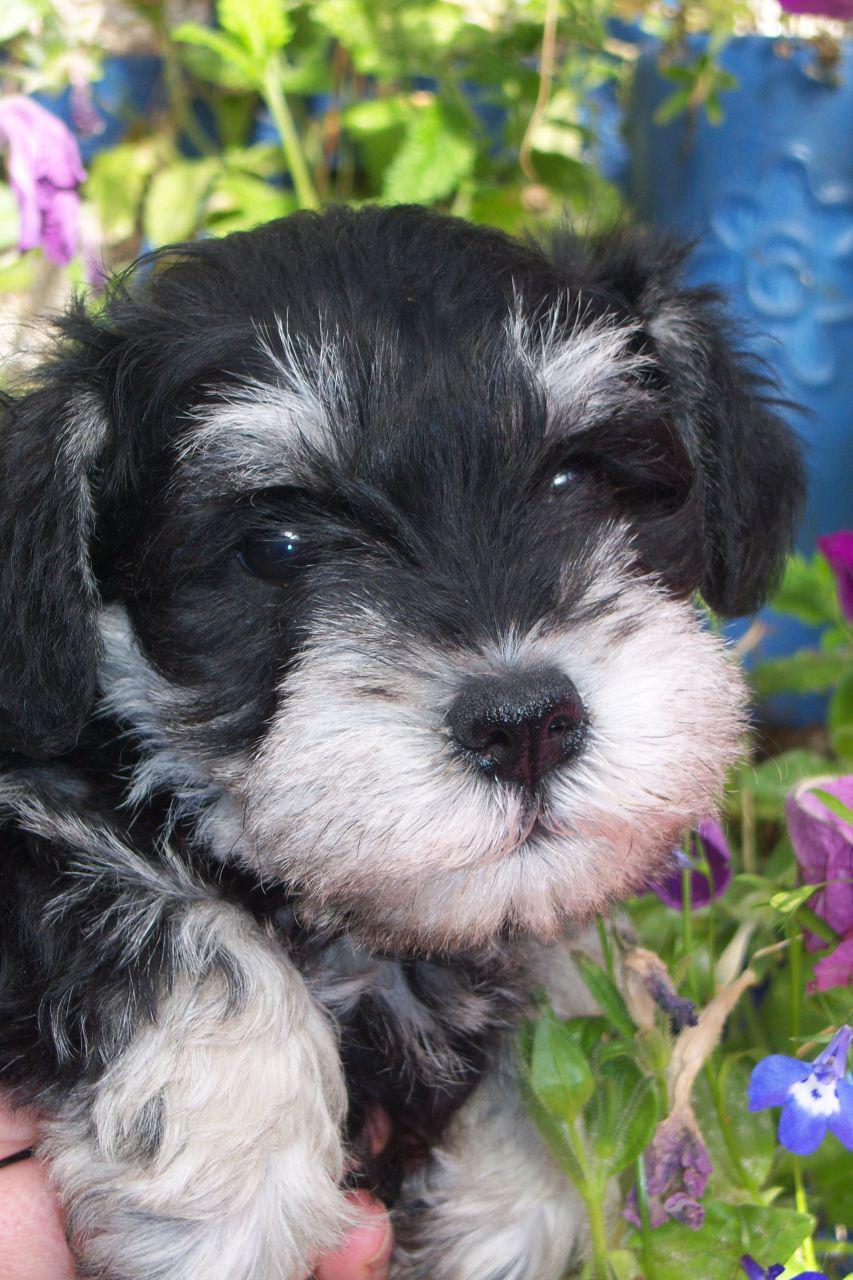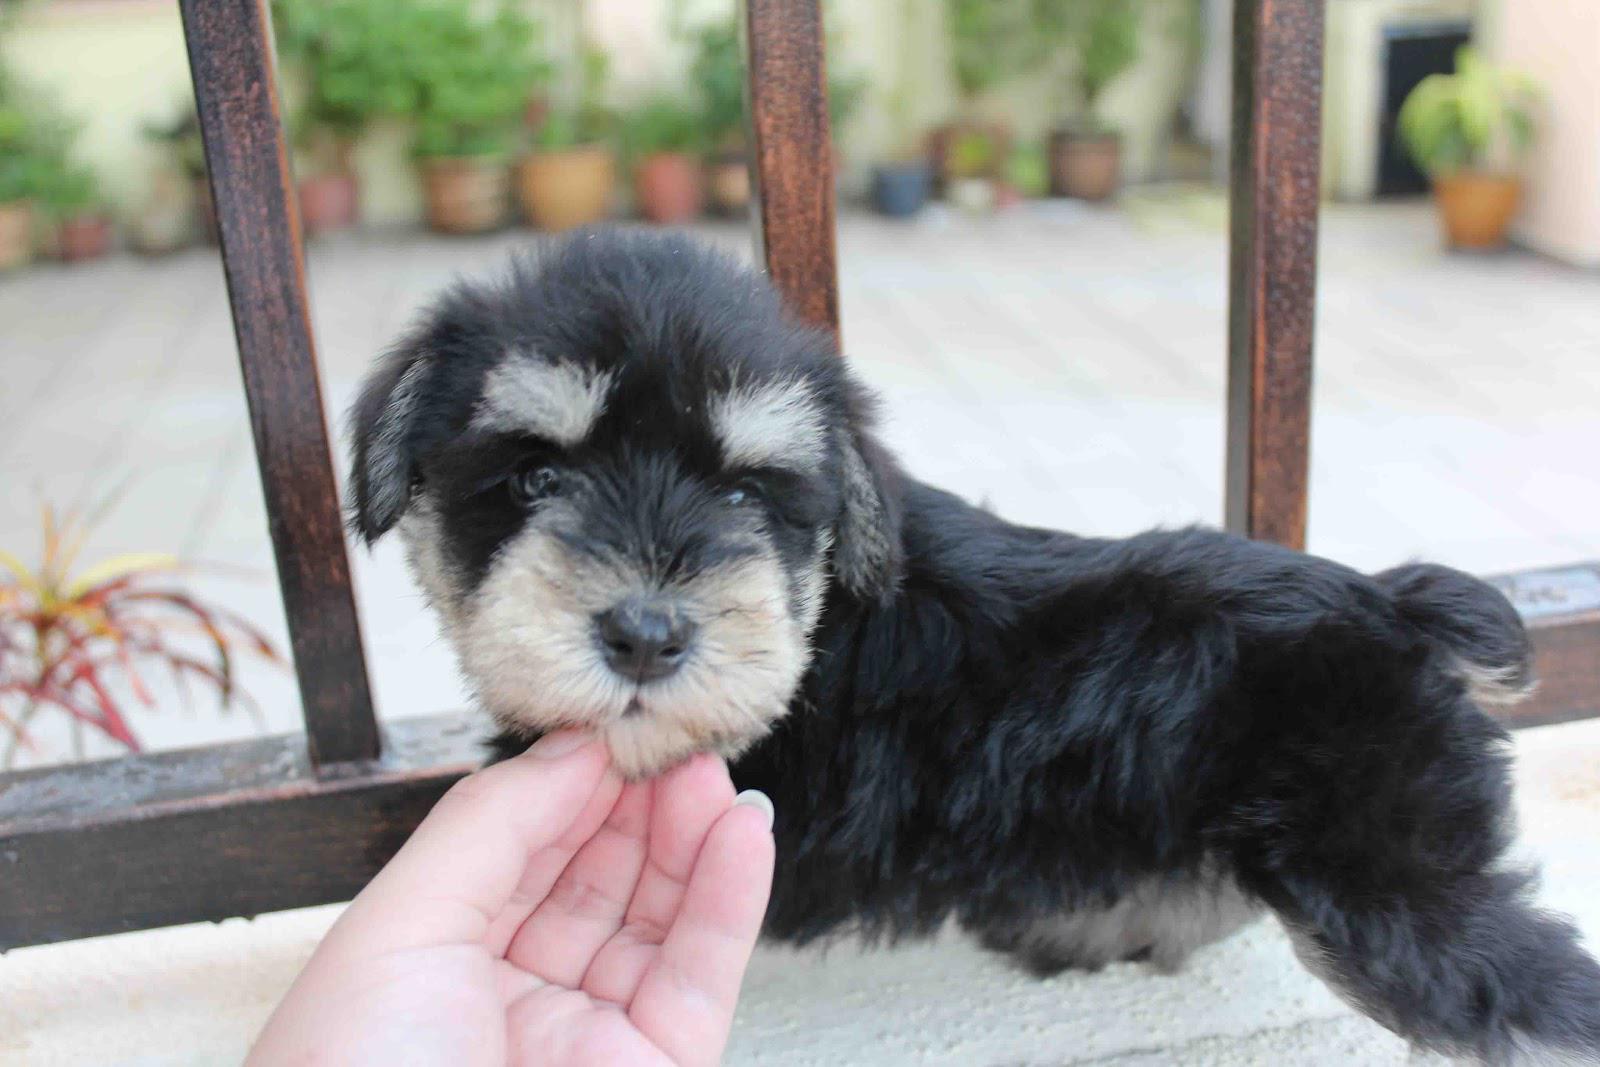The first image is the image on the left, the second image is the image on the right. Examine the images to the left and right. Is the description "All dogs are schnauzer puppies, and at least some dogs have white eyebrows." accurate? Answer yes or no. Yes. The first image is the image on the left, the second image is the image on the right. Analyze the images presented: Is the assertion "There are at least three dogs in the right image." valid? Answer yes or no. No. 